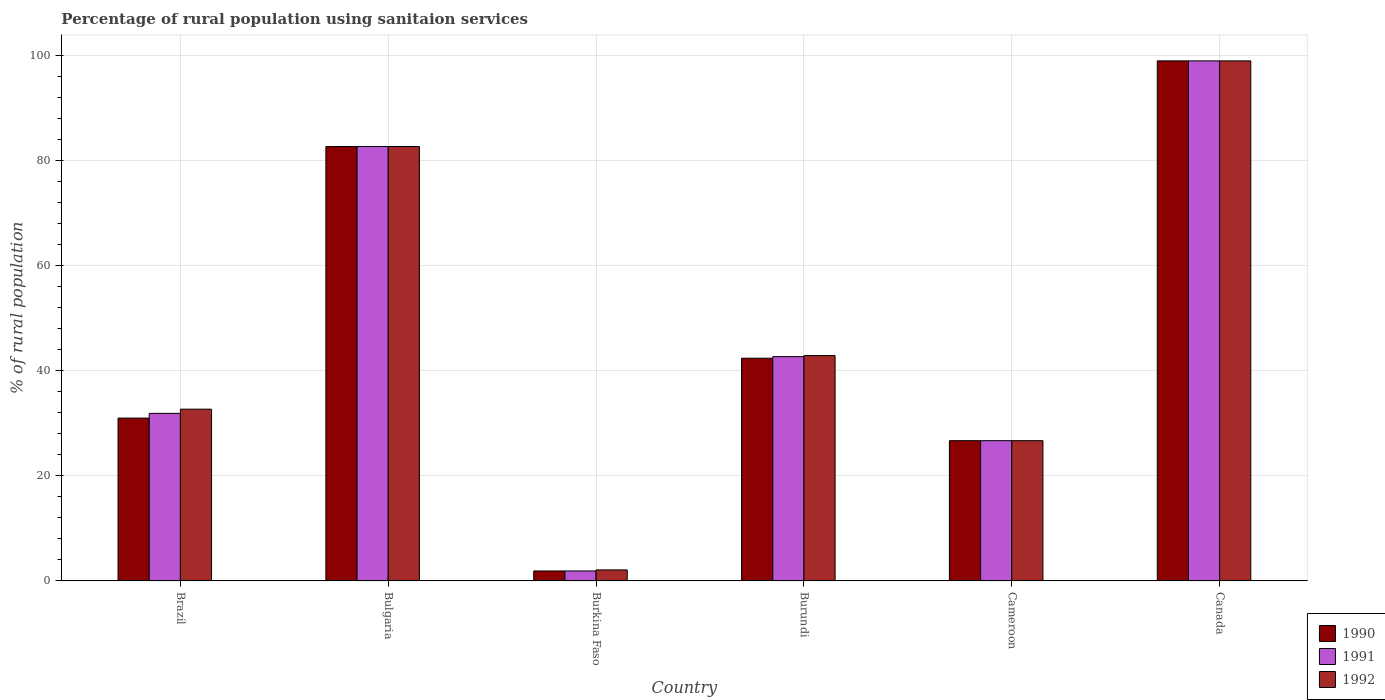How many different coloured bars are there?
Offer a very short reply. 3. How many groups of bars are there?
Your response must be concise. 6. Are the number of bars on each tick of the X-axis equal?
Your answer should be compact. Yes. How many bars are there on the 5th tick from the left?
Offer a terse response. 3. What is the percentage of rural population using sanitaion services in 1992 in Cameroon?
Provide a succinct answer. 26.7. Across all countries, what is the minimum percentage of rural population using sanitaion services in 1992?
Your answer should be very brief. 2.1. In which country was the percentage of rural population using sanitaion services in 1992 minimum?
Provide a short and direct response. Burkina Faso. What is the total percentage of rural population using sanitaion services in 1991 in the graph?
Offer a terse response. 284.9. What is the difference between the percentage of rural population using sanitaion services in 1992 in Bulgaria and that in Canada?
Provide a succinct answer. -16.3. What is the difference between the percentage of rural population using sanitaion services in 1991 in Canada and the percentage of rural population using sanitaion services in 1990 in Cameroon?
Offer a very short reply. 72.3. What is the average percentage of rural population using sanitaion services in 1991 per country?
Your answer should be very brief. 47.48. What is the ratio of the percentage of rural population using sanitaion services in 1992 in Burkina Faso to that in Cameroon?
Give a very brief answer. 0.08. What is the difference between the highest and the second highest percentage of rural population using sanitaion services in 1992?
Make the answer very short. -16.3. What is the difference between the highest and the lowest percentage of rural population using sanitaion services in 1990?
Your answer should be very brief. 97.1. Is the sum of the percentage of rural population using sanitaion services in 1991 in Bulgaria and Burundi greater than the maximum percentage of rural population using sanitaion services in 1992 across all countries?
Provide a short and direct response. Yes. What does the 2nd bar from the right in Bulgaria represents?
Your answer should be very brief. 1991. Are all the bars in the graph horizontal?
Offer a terse response. No. What is the difference between two consecutive major ticks on the Y-axis?
Offer a terse response. 20. Does the graph contain grids?
Your response must be concise. Yes. Where does the legend appear in the graph?
Offer a terse response. Bottom right. How many legend labels are there?
Offer a terse response. 3. How are the legend labels stacked?
Give a very brief answer. Vertical. What is the title of the graph?
Provide a short and direct response. Percentage of rural population using sanitaion services. What is the label or title of the X-axis?
Give a very brief answer. Country. What is the label or title of the Y-axis?
Your answer should be compact. % of rural population. What is the % of rural population of 1990 in Brazil?
Ensure brevity in your answer.  31. What is the % of rural population in 1991 in Brazil?
Your answer should be compact. 31.9. What is the % of rural population of 1992 in Brazil?
Give a very brief answer. 32.7. What is the % of rural population in 1990 in Bulgaria?
Give a very brief answer. 82.7. What is the % of rural population of 1991 in Bulgaria?
Keep it short and to the point. 82.7. What is the % of rural population in 1992 in Bulgaria?
Give a very brief answer. 82.7. What is the % of rural population in 1991 in Burkina Faso?
Keep it short and to the point. 1.9. What is the % of rural population in 1992 in Burkina Faso?
Your answer should be compact. 2.1. What is the % of rural population in 1990 in Burundi?
Your response must be concise. 42.4. What is the % of rural population of 1991 in Burundi?
Ensure brevity in your answer.  42.7. What is the % of rural population in 1992 in Burundi?
Give a very brief answer. 42.9. What is the % of rural population in 1990 in Cameroon?
Make the answer very short. 26.7. What is the % of rural population of 1991 in Cameroon?
Make the answer very short. 26.7. What is the % of rural population of 1992 in Cameroon?
Your response must be concise. 26.7. What is the % of rural population in 1990 in Canada?
Give a very brief answer. 99. What is the % of rural population in 1992 in Canada?
Ensure brevity in your answer.  99. Across all countries, what is the maximum % of rural population of 1991?
Ensure brevity in your answer.  99. Across all countries, what is the minimum % of rural population in 1991?
Provide a succinct answer. 1.9. Across all countries, what is the minimum % of rural population of 1992?
Provide a short and direct response. 2.1. What is the total % of rural population in 1990 in the graph?
Provide a short and direct response. 283.7. What is the total % of rural population of 1991 in the graph?
Your answer should be compact. 284.9. What is the total % of rural population in 1992 in the graph?
Your answer should be compact. 286.1. What is the difference between the % of rural population in 1990 in Brazil and that in Bulgaria?
Your answer should be compact. -51.7. What is the difference between the % of rural population in 1991 in Brazil and that in Bulgaria?
Ensure brevity in your answer.  -50.8. What is the difference between the % of rural population of 1990 in Brazil and that in Burkina Faso?
Your answer should be very brief. 29.1. What is the difference between the % of rural population of 1991 in Brazil and that in Burkina Faso?
Your answer should be very brief. 30. What is the difference between the % of rural population of 1992 in Brazil and that in Burkina Faso?
Offer a very short reply. 30.6. What is the difference between the % of rural population in 1990 in Brazil and that in Burundi?
Provide a succinct answer. -11.4. What is the difference between the % of rural population in 1991 in Brazil and that in Burundi?
Your answer should be compact. -10.8. What is the difference between the % of rural population in 1991 in Brazil and that in Cameroon?
Make the answer very short. 5.2. What is the difference between the % of rural population in 1992 in Brazil and that in Cameroon?
Your answer should be very brief. 6. What is the difference between the % of rural population of 1990 in Brazil and that in Canada?
Offer a terse response. -68. What is the difference between the % of rural population in 1991 in Brazil and that in Canada?
Offer a terse response. -67.1. What is the difference between the % of rural population in 1992 in Brazil and that in Canada?
Give a very brief answer. -66.3. What is the difference between the % of rural population in 1990 in Bulgaria and that in Burkina Faso?
Offer a terse response. 80.8. What is the difference between the % of rural population of 1991 in Bulgaria and that in Burkina Faso?
Provide a short and direct response. 80.8. What is the difference between the % of rural population of 1992 in Bulgaria and that in Burkina Faso?
Make the answer very short. 80.6. What is the difference between the % of rural population in 1990 in Bulgaria and that in Burundi?
Your answer should be very brief. 40.3. What is the difference between the % of rural population in 1991 in Bulgaria and that in Burundi?
Offer a terse response. 40. What is the difference between the % of rural population of 1992 in Bulgaria and that in Burundi?
Your answer should be very brief. 39.8. What is the difference between the % of rural population of 1991 in Bulgaria and that in Cameroon?
Give a very brief answer. 56. What is the difference between the % of rural population in 1992 in Bulgaria and that in Cameroon?
Give a very brief answer. 56. What is the difference between the % of rural population in 1990 in Bulgaria and that in Canada?
Offer a terse response. -16.3. What is the difference between the % of rural population in 1991 in Bulgaria and that in Canada?
Your response must be concise. -16.3. What is the difference between the % of rural population in 1992 in Bulgaria and that in Canada?
Your answer should be very brief. -16.3. What is the difference between the % of rural population of 1990 in Burkina Faso and that in Burundi?
Keep it short and to the point. -40.5. What is the difference between the % of rural population in 1991 in Burkina Faso and that in Burundi?
Provide a short and direct response. -40.8. What is the difference between the % of rural population in 1992 in Burkina Faso and that in Burundi?
Make the answer very short. -40.8. What is the difference between the % of rural population of 1990 in Burkina Faso and that in Cameroon?
Ensure brevity in your answer.  -24.8. What is the difference between the % of rural population in 1991 in Burkina Faso and that in Cameroon?
Your answer should be compact. -24.8. What is the difference between the % of rural population in 1992 in Burkina Faso and that in Cameroon?
Your answer should be compact. -24.6. What is the difference between the % of rural population in 1990 in Burkina Faso and that in Canada?
Your response must be concise. -97.1. What is the difference between the % of rural population of 1991 in Burkina Faso and that in Canada?
Provide a short and direct response. -97.1. What is the difference between the % of rural population of 1992 in Burkina Faso and that in Canada?
Your answer should be very brief. -96.9. What is the difference between the % of rural population in 1991 in Burundi and that in Cameroon?
Provide a short and direct response. 16. What is the difference between the % of rural population in 1990 in Burundi and that in Canada?
Your answer should be very brief. -56.6. What is the difference between the % of rural population in 1991 in Burundi and that in Canada?
Your answer should be compact. -56.3. What is the difference between the % of rural population in 1992 in Burundi and that in Canada?
Your answer should be compact. -56.1. What is the difference between the % of rural population in 1990 in Cameroon and that in Canada?
Your response must be concise. -72.3. What is the difference between the % of rural population of 1991 in Cameroon and that in Canada?
Offer a terse response. -72.3. What is the difference between the % of rural population in 1992 in Cameroon and that in Canada?
Offer a terse response. -72.3. What is the difference between the % of rural population in 1990 in Brazil and the % of rural population in 1991 in Bulgaria?
Ensure brevity in your answer.  -51.7. What is the difference between the % of rural population in 1990 in Brazil and the % of rural population in 1992 in Bulgaria?
Ensure brevity in your answer.  -51.7. What is the difference between the % of rural population of 1991 in Brazil and the % of rural population of 1992 in Bulgaria?
Provide a short and direct response. -50.8. What is the difference between the % of rural population in 1990 in Brazil and the % of rural population in 1991 in Burkina Faso?
Offer a terse response. 29.1. What is the difference between the % of rural population of 1990 in Brazil and the % of rural population of 1992 in Burkina Faso?
Your answer should be compact. 28.9. What is the difference between the % of rural population in 1991 in Brazil and the % of rural population in 1992 in Burkina Faso?
Give a very brief answer. 29.8. What is the difference between the % of rural population in 1990 in Brazil and the % of rural population in 1991 in Burundi?
Provide a succinct answer. -11.7. What is the difference between the % of rural population of 1991 in Brazil and the % of rural population of 1992 in Burundi?
Your answer should be very brief. -11. What is the difference between the % of rural population of 1990 in Brazil and the % of rural population of 1991 in Cameroon?
Keep it short and to the point. 4.3. What is the difference between the % of rural population of 1990 in Brazil and the % of rural population of 1992 in Cameroon?
Your answer should be very brief. 4.3. What is the difference between the % of rural population of 1990 in Brazil and the % of rural population of 1991 in Canada?
Ensure brevity in your answer.  -68. What is the difference between the % of rural population of 1990 in Brazil and the % of rural population of 1992 in Canada?
Make the answer very short. -68. What is the difference between the % of rural population in 1991 in Brazil and the % of rural population in 1992 in Canada?
Ensure brevity in your answer.  -67.1. What is the difference between the % of rural population of 1990 in Bulgaria and the % of rural population of 1991 in Burkina Faso?
Provide a short and direct response. 80.8. What is the difference between the % of rural population in 1990 in Bulgaria and the % of rural population in 1992 in Burkina Faso?
Make the answer very short. 80.6. What is the difference between the % of rural population of 1991 in Bulgaria and the % of rural population of 1992 in Burkina Faso?
Offer a terse response. 80.6. What is the difference between the % of rural population of 1990 in Bulgaria and the % of rural population of 1992 in Burundi?
Offer a terse response. 39.8. What is the difference between the % of rural population in 1991 in Bulgaria and the % of rural population in 1992 in Burundi?
Ensure brevity in your answer.  39.8. What is the difference between the % of rural population of 1990 in Bulgaria and the % of rural population of 1991 in Cameroon?
Your response must be concise. 56. What is the difference between the % of rural population of 1990 in Bulgaria and the % of rural population of 1992 in Cameroon?
Provide a short and direct response. 56. What is the difference between the % of rural population of 1990 in Bulgaria and the % of rural population of 1991 in Canada?
Your response must be concise. -16.3. What is the difference between the % of rural population of 1990 in Bulgaria and the % of rural population of 1992 in Canada?
Keep it short and to the point. -16.3. What is the difference between the % of rural population in 1991 in Bulgaria and the % of rural population in 1992 in Canada?
Offer a very short reply. -16.3. What is the difference between the % of rural population in 1990 in Burkina Faso and the % of rural population in 1991 in Burundi?
Your answer should be compact. -40.8. What is the difference between the % of rural population in 1990 in Burkina Faso and the % of rural population in 1992 in Burundi?
Make the answer very short. -41. What is the difference between the % of rural population in 1991 in Burkina Faso and the % of rural population in 1992 in Burundi?
Your answer should be very brief. -41. What is the difference between the % of rural population in 1990 in Burkina Faso and the % of rural population in 1991 in Cameroon?
Provide a succinct answer. -24.8. What is the difference between the % of rural population in 1990 in Burkina Faso and the % of rural population in 1992 in Cameroon?
Provide a short and direct response. -24.8. What is the difference between the % of rural population of 1991 in Burkina Faso and the % of rural population of 1992 in Cameroon?
Provide a succinct answer. -24.8. What is the difference between the % of rural population in 1990 in Burkina Faso and the % of rural population in 1991 in Canada?
Offer a very short reply. -97.1. What is the difference between the % of rural population of 1990 in Burkina Faso and the % of rural population of 1992 in Canada?
Ensure brevity in your answer.  -97.1. What is the difference between the % of rural population of 1991 in Burkina Faso and the % of rural population of 1992 in Canada?
Make the answer very short. -97.1. What is the difference between the % of rural population in 1990 in Burundi and the % of rural population in 1991 in Canada?
Ensure brevity in your answer.  -56.6. What is the difference between the % of rural population in 1990 in Burundi and the % of rural population in 1992 in Canada?
Keep it short and to the point. -56.6. What is the difference between the % of rural population of 1991 in Burundi and the % of rural population of 1992 in Canada?
Ensure brevity in your answer.  -56.3. What is the difference between the % of rural population in 1990 in Cameroon and the % of rural population in 1991 in Canada?
Offer a terse response. -72.3. What is the difference between the % of rural population in 1990 in Cameroon and the % of rural population in 1992 in Canada?
Your answer should be very brief. -72.3. What is the difference between the % of rural population in 1991 in Cameroon and the % of rural population in 1992 in Canada?
Provide a short and direct response. -72.3. What is the average % of rural population in 1990 per country?
Provide a short and direct response. 47.28. What is the average % of rural population of 1991 per country?
Provide a short and direct response. 47.48. What is the average % of rural population in 1992 per country?
Your answer should be very brief. 47.68. What is the difference between the % of rural population of 1990 and % of rural population of 1991 in Brazil?
Give a very brief answer. -0.9. What is the difference between the % of rural population of 1991 and % of rural population of 1992 in Brazil?
Offer a very short reply. -0.8. What is the difference between the % of rural population of 1990 and % of rural population of 1991 in Burkina Faso?
Offer a very short reply. 0. What is the difference between the % of rural population in 1990 and % of rural population in 1992 in Burkina Faso?
Provide a short and direct response. -0.2. What is the difference between the % of rural population in 1991 and % of rural population in 1992 in Burkina Faso?
Offer a terse response. -0.2. What is the difference between the % of rural population in 1990 and % of rural population in 1991 in Burundi?
Provide a succinct answer. -0.3. What is the difference between the % of rural population of 1990 and % of rural population of 1991 in Canada?
Make the answer very short. 0. What is the difference between the % of rural population in 1990 and % of rural population in 1992 in Canada?
Your answer should be compact. 0. What is the difference between the % of rural population of 1991 and % of rural population of 1992 in Canada?
Keep it short and to the point. 0. What is the ratio of the % of rural population in 1990 in Brazil to that in Bulgaria?
Offer a very short reply. 0.37. What is the ratio of the % of rural population in 1991 in Brazil to that in Bulgaria?
Offer a terse response. 0.39. What is the ratio of the % of rural population of 1992 in Brazil to that in Bulgaria?
Your answer should be very brief. 0.4. What is the ratio of the % of rural population of 1990 in Brazil to that in Burkina Faso?
Provide a succinct answer. 16.32. What is the ratio of the % of rural population in 1991 in Brazil to that in Burkina Faso?
Make the answer very short. 16.79. What is the ratio of the % of rural population of 1992 in Brazil to that in Burkina Faso?
Give a very brief answer. 15.57. What is the ratio of the % of rural population in 1990 in Brazil to that in Burundi?
Offer a very short reply. 0.73. What is the ratio of the % of rural population of 1991 in Brazil to that in Burundi?
Your answer should be very brief. 0.75. What is the ratio of the % of rural population of 1992 in Brazil to that in Burundi?
Ensure brevity in your answer.  0.76. What is the ratio of the % of rural population in 1990 in Brazil to that in Cameroon?
Provide a succinct answer. 1.16. What is the ratio of the % of rural population of 1991 in Brazil to that in Cameroon?
Provide a succinct answer. 1.19. What is the ratio of the % of rural population of 1992 in Brazil to that in Cameroon?
Provide a short and direct response. 1.22. What is the ratio of the % of rural population of 1990 in Brazil to that in Canada?
Your response must be concise. 0.31. What is the ratio of the % of rural population in 1991 in Brazil to that in Canada?
Your answer should be compact. 0.32. What is the ratio of the % of rural population of 1992 in Brazil to that in Canada?
Ensure brevity in your answer.  0.33. What is the ratio of the % of rural population of 1990 in Bulgaria to that in Burkina Faso?
Your answer should be compact. 43.53. What is the ratio of the % of rural population of 1991 in Bulgaria to that in Burkina Faso?
Give a very brief answer. 43.53. What is the ratio of the % of rural population of 1992 in Bulgaria to that in Burkina Faso?
Keep it short and to the point. 39.38. What is the ratio of the % of rural population of 1990 in Bulgaria to that in Burundi?
Offer a terse response. 1.95. What is the ratio of the % of rural population of 1991 in Bulgaria to that in Burundi?
Your answer should be very brief. 1.94. What is the ratio of the % of rural population of 1992 in Bulgaria to that in Burundi?
Make the answer very short. 1.93. What is the ratio of the % of rural population in 1990 in Bulgaria to that in Cameroon?
Make the answer very short. 3.1. What is the ratio of the % of rural population in 1991 in Bulgaria to that in Cameroon?
Give a very brief answer. 3.1. What is the ratio of the % of rural population in 1992 in Bulgaria to that in Cameroon?
Ensure brevity in your answer.  3.1. What is the ratio of the % of rural population in 1990 in Bulgaria to that in Canada?
Offer a very short reply. 0.84. What is the ratio of the % of rural population of 1991 in Bulgaria to that in Canada?
Provide a succinct answer. 0.84. What is the ratio of the % of rural population in 1992 in Bulgaria to that in Canada?
Make the answer very short. 0.84. What is the ratio of the % of rural population of 1990 in Burkina Faso to that in Burundi?
Make the answer very short. 0.04. What is the ratio of the % of rural population in 1991 in Burkina Faso to that in Burundi?
Make the answer very short. 0.04. What is the ratio of the % of rural population of 1992 in Burkina Faso to that in Burundi?
Offer a very short reply. 0.05. What is the ratio of the % of rural population of 1990 in Burkina Faso to that in Cameroon?
Make the answer very short. 0.07. What is the ratio of the % of rural population in 1991 in Burkina Faso to that in Cameroon?
Your answer should be very brief. 0.07. What is the ratio of the % of rural population of 1992 in Burkina Faso to that in Cameroon?
Keep it short and to the point. 0.08. What is the ratio of the % of rural population in 1990 in Burkina Faso to that in Canada?
Keep it short and to the point. 0.02. What is the ratio of the % of rural population in 1991 in Burkina Faso to that in Canada?
Your response must be concise. 0.02. What is the ratio of the % of rural population in 1992 in Burkina Faso to that in Canada?
Provide a succinct answer. 0.02. What is the ratio of the % of rural population of 1990 in Burundi to that in Cameroon?
Your answer should be very brief. 1.59. What is the ratio of the % of rural population of 1991 in Burundi to that in Cameroon?
Your answer should be very brief. 1.6. What is the ratio of the % of rural population of 1992 in Burundi to that in Cameroon?
Offer a very short reply. 1.61. What is the ratio of the % of rural population in 1990 in Burundi to that in Canada?
Give a very brief answer. 0.43. What is the ratio of the % of rural population in 1991 in Burundi to that in Canada?
Keep it short and to the point. 0.43. What is the ratio of the % of rural population in 1992 in Burundi to that in Canada?
Offer a very short reply. 0.43. What is the ratio of the % of rural population of 1990 in Cameroon to that in Canada?
Your answer should be compact. 0.27. What is the ratio of the % of rural population of 1991 in Cameroon to that in Canada?
Your response must be concise. 0.27. What is the ratio of the % of rural population of 1992 in Cameroon to that in Canada?
Offer a very short reply. 0.27. What is the difference between the highest and the second highest % of rural population of 1992?
Your answer should be compact. 16.3. What is the difference between the highest and the lowest % of rural population in 1990?
Offer a very short reply. 97.1. What is the difference between the highest and the lowest % of rural population in 1991?
Offer a terse response. 97.1. What is the difference between the highest and the lowest % of rural population in 1992?
Offer a terse response. 96.9. 